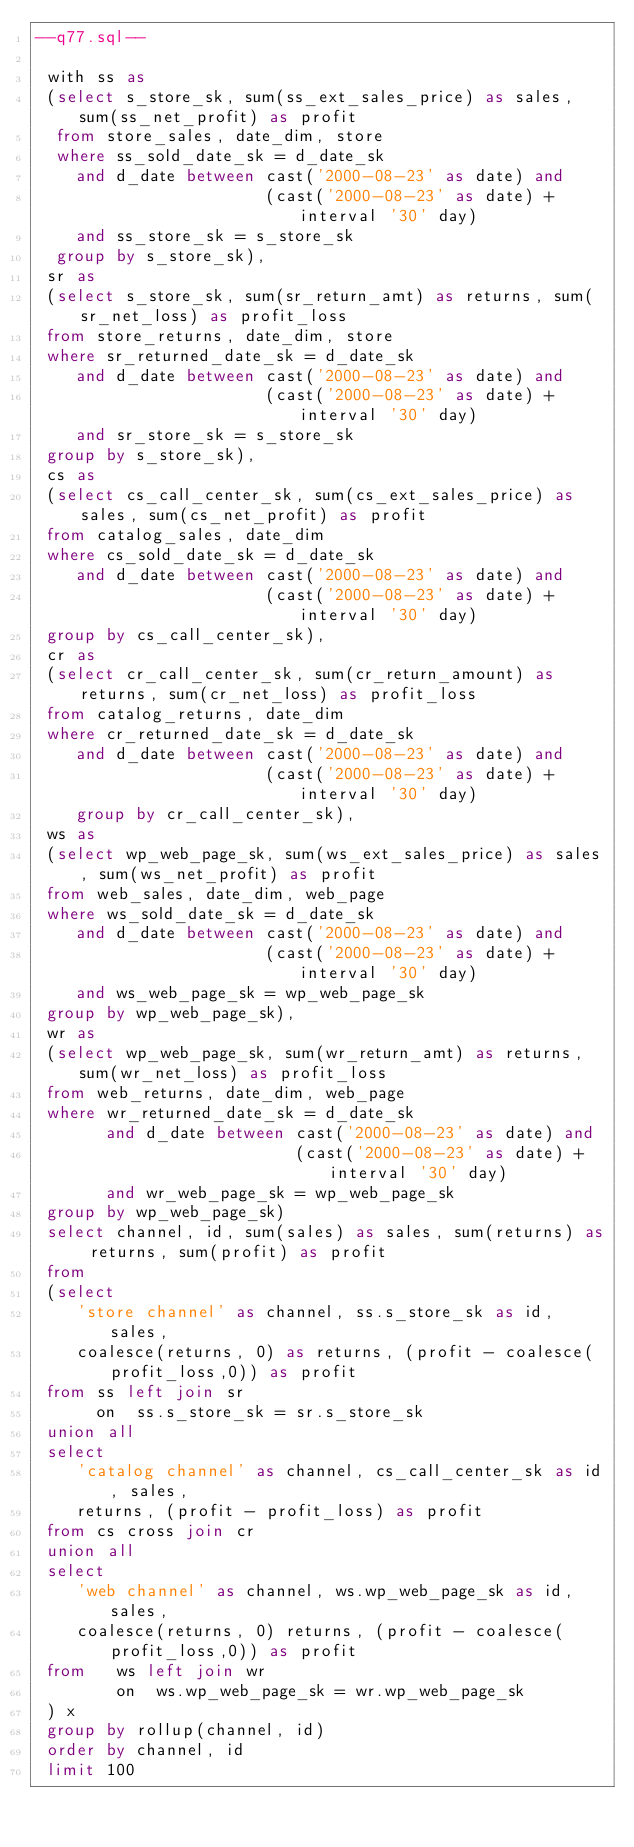<code> <loc_0><loc_0><loc_500><loc_500><_SQL_>--q77.sql--

 with ss as
 (select s_store_sk, sum(ss_ext_sales_price) as sales, sum(ss_net_profit) as profit
  from store_sales, date_dim, store
  where ss_sold_date_sk = d_date_sk
    and d_date between cast('2000-08-23' as date) and
                       (cast('2000-08-23' as date) + interval '30' day)
    and ss_store_sk = s_store_sk
  group by s_store_sk),
 sr as
 (select s_store_sk, sum(sr_return_amt) as returns, sum(sr_net_loss) as profit_loss
 from store_returns, date_dim, store
 where sr_returned_date_sk = d_date_sk
    and d_date between cast('2000-08-23' as date) and
                       (cast('2000-08-23' as date) + interval '30' day)
    and sr_store_sk = s_store_sk
 group by s_store_sk),
 cs as
 (select cs_call_center_sk, sum(cs_ext_sales_price) as sales, sum(cs_net_profit) as profit
 from catalog_sales, date_dim
 where cs_sold_date_sk = d_date_sk
    and d_date between cast('2000-08-23' as date) and
                       (cast('2000-08-23' as date) + interval '30' day)
 group by cs_call_center_sk),
 cr as
 (select cr_call_center_sk, sum(cr_return_amount) as returns, sum(cr_net_loss) as profit_loss
 from catalog_returns, date_dim
 where cr_returned_date_sk = d_date_sk
    and d_date between cast('2000-08-23' as date) and
                       (cast('2000-08-23' as date) + interval '30' day)
	group by cr_call_center_sk),
 ws as
 (select wp_web_page_sk, sum(ws_ext_sales_price) as sales, sum(ws_net_profit) as profit
 from web_sales, date_dim, web_page
 where ws_sold_date_sk = d_date_sk
    and d_date between cast('2000-08-23' as date) and
                       (cast('2000-08-23' as date) + interval '30' day)
    and ws_web_page_sk = wp_web_page_sk
 group by wp_web_page_sk),
 wr as
 (select wp_web_page_sk, sum(wr_return_amt) as returns, sum(wr_net_loss) as profit_loss
 from web_returns, date_dim, web_page
 where wr_returned_date_sk = d_date_sk
       and d_date between cast('2000-08-23' as date) and
                          (cast('2000-08-23' as date) + interval '30' day)
       and wr_web_page_sk = wp_web_page_sk
 group by wp_web_page_sk)
 select channel, id, sum(sales) as sales, sum(returns) as returns, sum(profit) as profit
 from
 (select
    'store channel' as channel, ss.s_store_sk as id, sales,
    coalesce(returns, 0) as returns, (profit - coalesce(profit_loss,0)) as profit
 from ss left join sr
      on  ss.s_store_sk = sr.s_store_sk
 union all
 select
    'catalog channel' as channel, cs_call_center_sk as id, sales,
    returns, (profit - profit_loss) as profit
 from cs cross join cr
 union all
 select
    'web channel' as channel, ws.wp_web_page_sk as id, sales,
    coalesce(returns, 0) returns, (profit - coalesce(profit_loss,0)) as profit
 from   ws left join wr
        on  ws.wp_web_page_sk = wr.wp_web_page_sk
 ) x
 group by rollup(channel, id)
 order by channel, id
 limit 100
            
</code> 